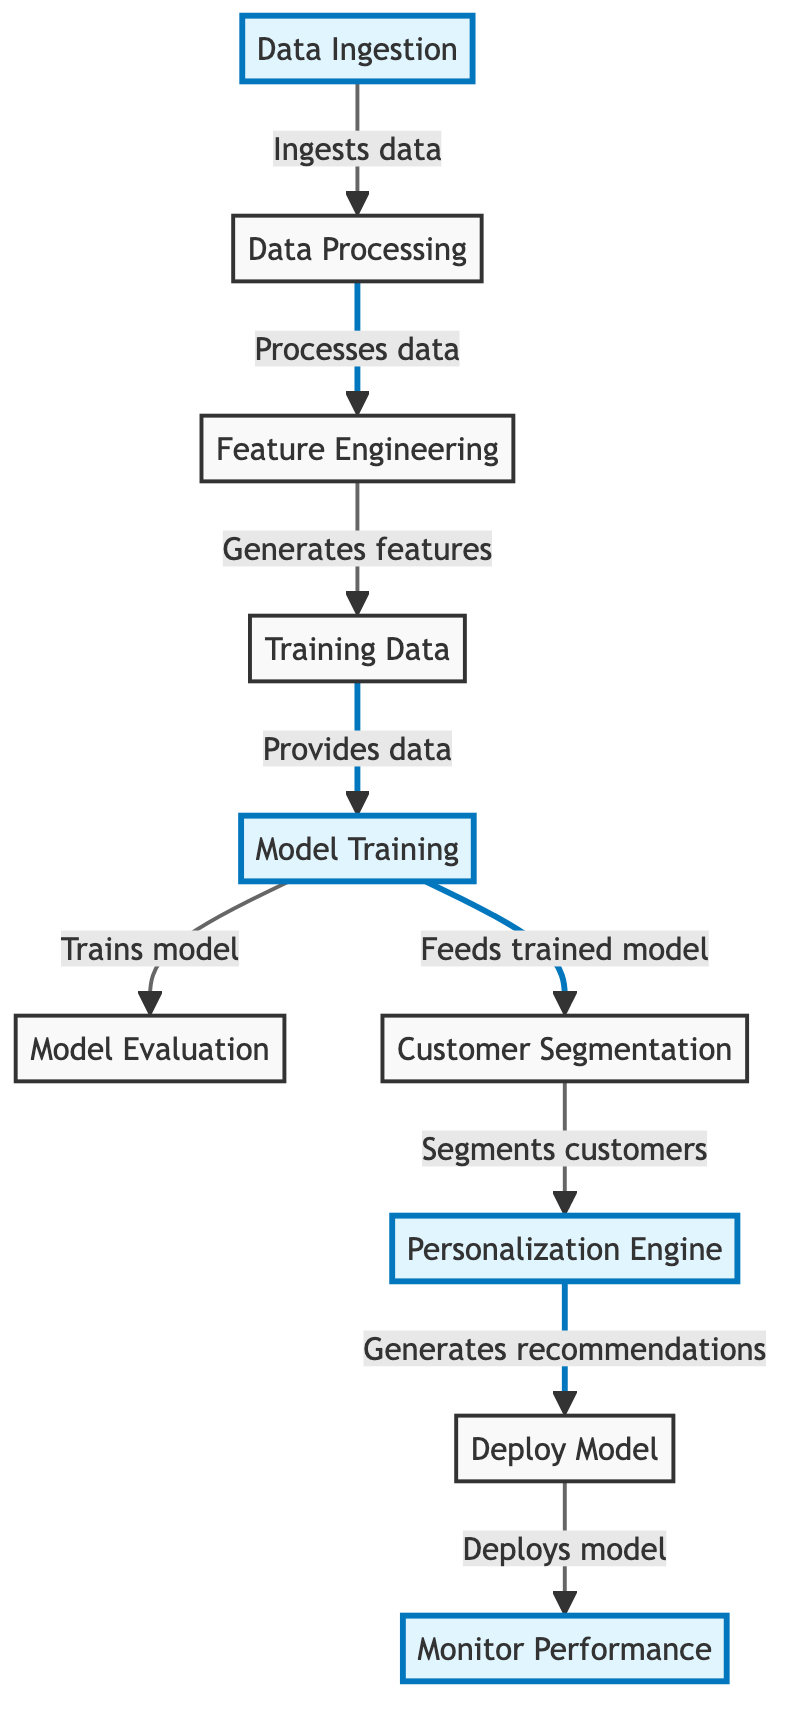What is the first step in the diagram? The diagram starts with the node labeled "Data Ingestion," which indicates that the first step involves gathering or ingesting data before any processes take place.
Answer: Data Ingestion How many main nodes are there in the diagram? By counting the distinct nodes shown in the diagram, we identify a total of 10 nodes representing different steps in the personalization engine performance and customer segmentation process.
Answer: 10 Which node is responsible for generating recommendations? The node labeled "Personalization Engine" is tasked with generating recommendations based on the segments created from customer data.
Answer: Personalization Engine What node follows "Model Training"? The node that directly follows "Model Training" is "Model Evaluation," indicating that after the model is trained, it must be evaluated before further actions are taken.
Answer: Model Evaluation Which process involves segmentation of customers? The process that involves the segmentation of customers is labeled "Customer Segmentation," which takes the trained model and segments the customer base based on specific criteria.
Answer: Customer Segmentation What connections are highlighted in this diagram? The connections highlighted are those from "Data Ingestion" to "Data Processing," "Model Training" to "Customer Segmentation," and "Personalization Engine" to "Monitor Performance," emphasizing key relationships in the workflow.
Answer: Data Ingestion to Data Processing, Model Training to Customer Segmentation, Personalization Engine to Monitor Performance What happens after the "Deploy Model" step? After the "Deploy Model" step, the final action in the diagram is to "Monitor Performance," which indicates that once the model is deployed, its performance is continuously monitored to ensure effectiveness and relevance.
Answer: Monitor Performance Which step processes the data? The step that processes the data is labeled "Data Processing," which indicates that the ingestion of data is followed by processing it into a usable format for further analysis and feature generation.
Answer: Data Processing How does the model reach the "Deploy Model" stage? The model reaches the "Deploy Model" stage by first undergoing "Model Training" after which the trained model is fed into the deployment phase, demonstrating the flow of data from training to deployment in the overall process.
Answer: Model Training to Deploy Model 